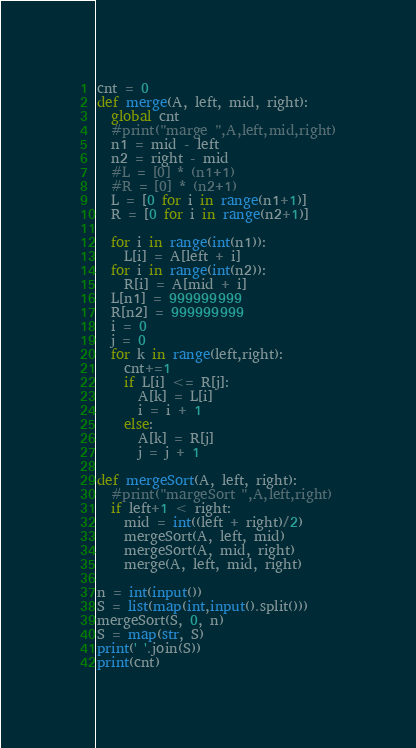Convert code to text. <code><loc_0><loc_0><loc_500><loc_500><_Python_>cnt = 0
def merge(A, left, mid, right):
  global cnt
  #print("marge ",A,left,mid,right)
  n1 = mid - left
  n2 = right - mid
  #L = [0] * (n1+1)
  #R = [0] * (n2+1)
  L = [0 for i in range(n1+1)]
  R = [0 for i in range(n2+1)]
  
  for i in range(int(n1)):
    L[i] = A[left + i]
  for i in range(int(n2)):
    R[i] = A[mid + i]
  L[n1] = 999999999
  R[n2] = 999999999
  i = 0
  j = 0
  for k in range(left,right):
    cnt+=1
    if L[i] <= R[j]:
      A[k] = L[i]
      i = i + 1
    else:
      A[k] = R[j]
      j = j + 1

def mergeSort(A, left, right):
  #print("margeSort ",A,left,right)
  if left+1 < right:
    mid = int((left + right)/2)
    mergeSort(A, left, mid)
    mergeSort(A, mid, right)
    merge(A, left, mid, right)

n = int(input())
S = list(map(int,input().split()))
mergeSort(S, 0, n)
S = map(str, S)
print(' '.join(S))
print(cnt)
</code> 